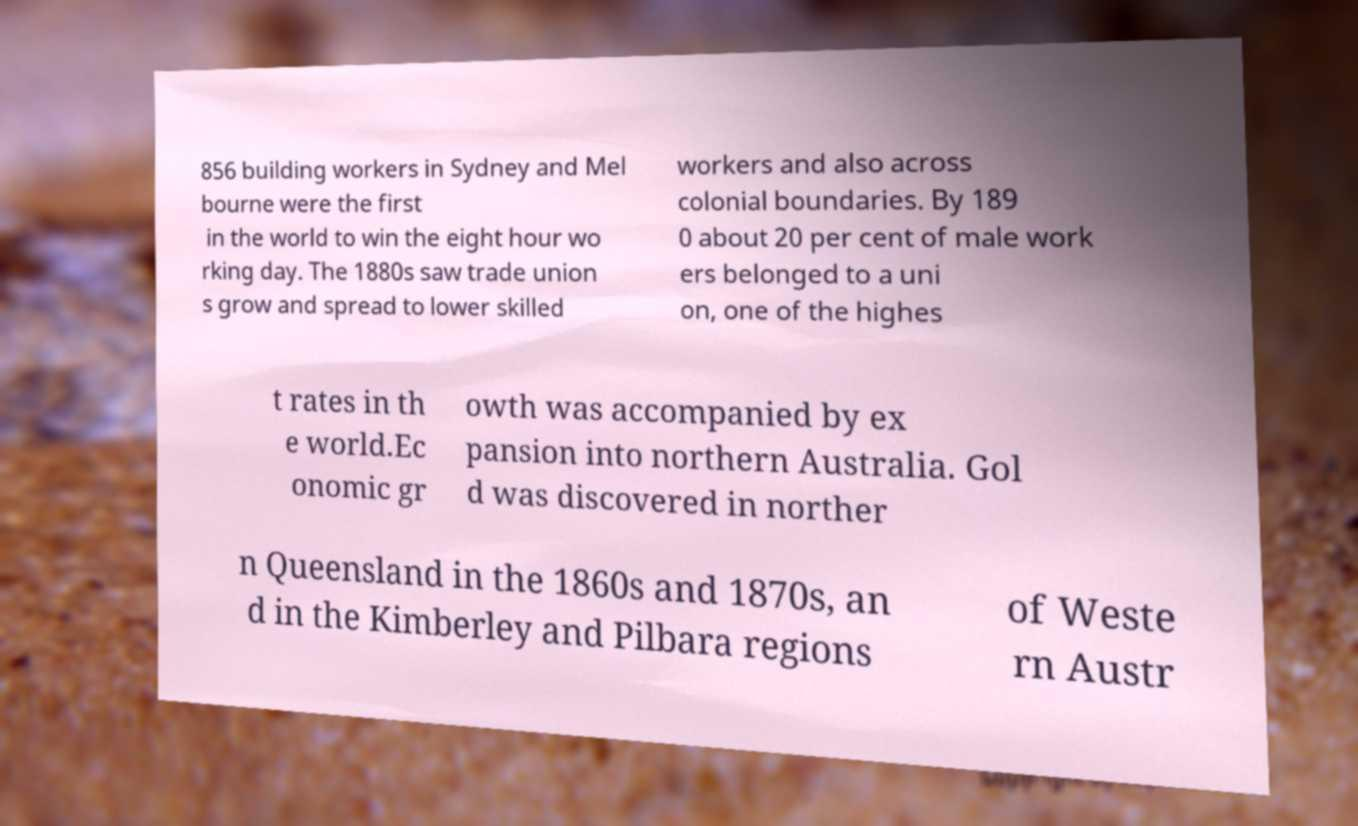Please identify and transcribe the text found in this image. 856 building workers in Sydney and Mel bourne were the first in the world to win the eight hour wo rking day. The 1880s saw trade union s grow and spread to lower skilled workers and also across colonial boundaries. By 189 0 about 20 per cent of male work ers belonged to a uni on, one of the highes t rates in th e world.Ec onomic gr owth was accompanied by ex pansion into northern Australia. Gol d was discovered in norther n Queensland in the 1860s and 1870s, an d in the Kimberley and Pilbara regions of Weste rn Austr 